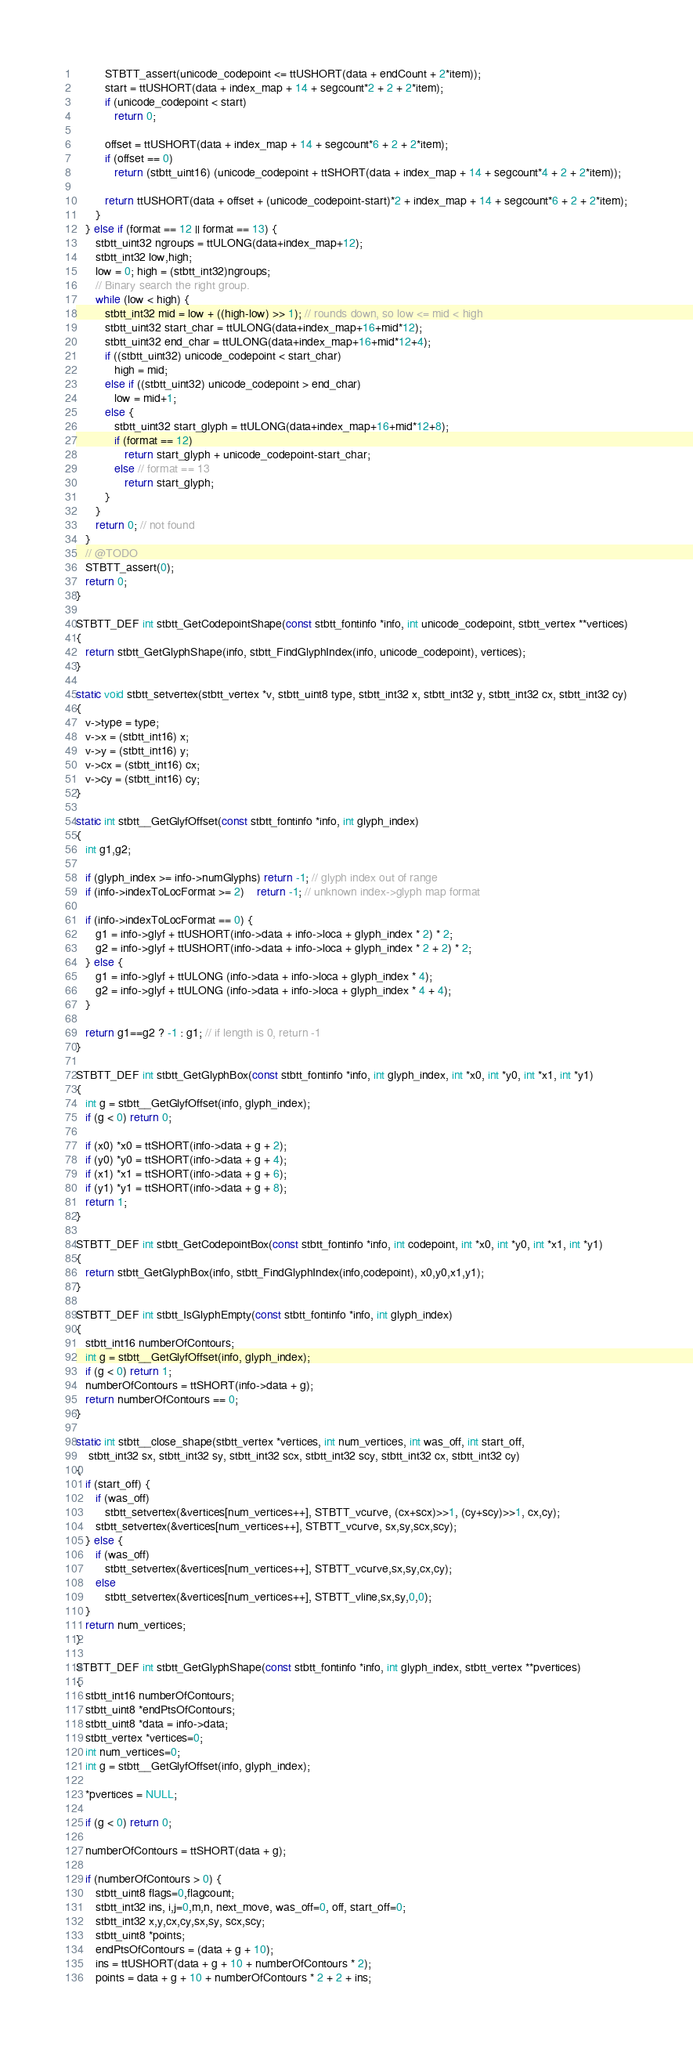Convert code to text. <code><loc_0><loc_0><loc_500><loc_500><_C_>         STBTT_assert(unicode_codepoint <= ttUSHORT(data + endCount + 2*item));
         start = ttUSHORT(data + index_map + 14 + segcount*2 + 2 + 2*item);
         if (unicode_codepoint < start)
            return 0;

         offset = ttUSHORT(data + index_map + 14 + segcount*6 + 2 + 2*item);
         if (offset == 0)
            return (stbtt_uint16) (unicode_codepoint + ttSHORT(data + index_map + 14 + segcount*4 + 2 + 2*item));

         return ttUSHORT(data + offset + (unicode_codepoint-start)*2 + index_map + 14 + segcount*6 + 2 + 2*item);
      }
   } else if (format == 12 || format == 13) {
      stbtt_uint32 ngroups = ttULONG(data+index_map+12);
      stbtt_int32 low,high;
      low = 0; high = (stbtt_int32)ngroups;
      // Binary search the right group.
      while (low < high) {
         stbtt_int32 mid = low + ((high-low) >> 1); // rounds down, so low <= mid < high
         stbtt_uint32 start_char = ttULONG(data+index_map+16+mid*12);
         stbtt_uint32 end_char = ttULONG(data+index_map+16+mid*12+4);
         if ((stbtt_uint32) unicode_codepoint < start_char)
            high = mid;
         else if ((stbtt_uint32) unicode_codepoint > end_char)
            low = mid+1;
         else {
            stbtt_uint32 start_glyph = ttULONG(data+index_map+16+mid*12+8);
            if (format == 12)
               return start_glyph + unicode_codepoint-start_char;
            else // format == 13
               return start_glyph;
         }
      }
      return 0; // not found
   }
   // @TODO
   STBTT_assert(0);
   return 0;
}

STBTT_DEF int stbtt_GetCodepointShape(const stbtt_fontinfo *info, int unicode_codepoint, stbtt_vertex **vertices)
{
   return stbtt_GetGlyphShape(info, stbtt_FindGlyphIndex(info, unicode_codepoint), vertices);
}

static void stbtt_setvertex(stbtt_vertex *v, stbtt_uint8 type, stbtt_int32 x, stbtt_int32 y, stbtt_int32 cx, stbtt_int32 cy)
{
   v->type = type;
   v->x = (stbtt_int16) x;
   v->y = (stbtt_int16) y;
   v->cx = (stbtt_int16) cx;
   v->cy = (stbtt_int16) cy;
}

static int stbtt__GetGlyfOffset(const stbtt_fontinfo *info, int glyph_index)
{
   int g1,g2;

   if (glyph_index >= info->numGlyphs) return -1; // glyph index out of range
   if (info->indexToLocFormat >= 2)    return -1; // unknown index->glyph map format

   if (info->indexToLocFormat == 0) {
      g1 = info->glyf + ttUSHORT(info->data + info->loca + glyph_index * 2) * 2;
      g2 = info->glyf + ttUSHORT(info->data + info->loca + glyph_index * 2 + 2) * 2;
   } else {
      g1 = info->glyf + ttULONG (info->data + info->loca + glyph_index * 4);
      g2 = info->glyf + ttULONG (info->data + info->loca + glyph_index * 4 + 4);
   }

   return g1==g2 ? -1 : g1; // if length is 0, return -1
}

STBTT_DEF int stbtt_GetGlyphBox(const stbtt_fontinfo *info, int glyph_index, int *x0, int *y0, int *x1, int *y1)
{
   int g = stbtt__GetGlyfOffset(info, glyph_index);
   if (g < 0) return 0;

   if (x0) *x0 = ttSHORT(info->data + g + 2);
   if (y0) *y0 = ttSHORT(info->data + g + 4);
   if (x1) *x1 = ttSHORT(info->data + g + 6);
   if (y1) *y1 = ttSHORT(info->data + g + 8);
   return 1;
}

STBTT_DEF int stbtt_GetCodepointBox(const stbtt_fontinfo *info, int codepoint, int *x0, int *y0, int *x1, int *y1)
{
   return stbtt_GetGlyphBox(info, stbtt_FindGlyphIndex(info,codepoint), x0,y0,x1,y1);
}

STBTT_DEF int stbtt_IsGlyphEmpty(const stbtt_fontinfo *info, int glyph_index)
{
   stbtt_int16 numberOfContours;
   int g = stbtt__GetGlyfOffset(info, glyph_index);
   if (g < 0) return 1;
   numberOfContours = ttSHORT(info->data + g);
   return numberOfContours == 0;
}

static int stbtt__close_shape(stbtt_vertex *vertices, int num_vertices, int was_off, int start_off,
    stbtt_int32 sx, stbtt_int32 sy, stbtt_int32 scx, stbtt_int32 scy, stbtt_int32 cx, stbtt_int32 cy)
{
   if (start_off) {
      if (was_off)
         stbtt_setvertex(&vertices[num_vertices++], STBTT_vcurve, (cx+scx)>>1, (cy+scy)>>1, cx,cy);
      stbtt_setvertex(&vertices[num_vertices++], STBTT_vcurve, sx,sy,scx,scy);
   } else {
      if (was_off)
         stbtt_setvertex(&vertices[num_vertices++], STBTT_vcurve,sx,sy,cx,cy);
      else
         stbtt_setvertex(&vertices[num_vertices++], STBTT_vline,sx,sy,0,0);
   }
   return num_vertices;
}

STBTT_DEF int stbtt_GetGlyphShape(const stbtt_fontinfo *info, int glyph_index, stbtt_vertex **pvertices)
{
   stbtt_int16 numberOfContours;
   stbtt_uint8 *endPtsOfContours;
   stbtt_uint8 *data = info->data;
   stbtt_vertex *vertices=0;
   int num_vertices=0;
   int g = stbtt__GetGlyfOffset(info, glyph_index);

   *pvertices = NULL;

   if (g < 0) return 0;

   numberOfContours = ttSHORT(data + g);

   if (numberOfContours > 0) {
      stbtt_uint8 flags=0,flagcount;
      stbtt_int32 ins, i,j=0,m,n, next_move, was_off=0, off, start_off=0;
      stbtt_int32 x,y,cx,cy,sx,sy, scx,scy;
      stbtt_uint8 *points;
      endPtsOfContours = (data + g + 10);
      ins = ttUSHORT(data + g + 10 + numberOfContours * 2);
      points = data + g + 10 + numberOfContours * 2 + 2 + ins;
</code> 